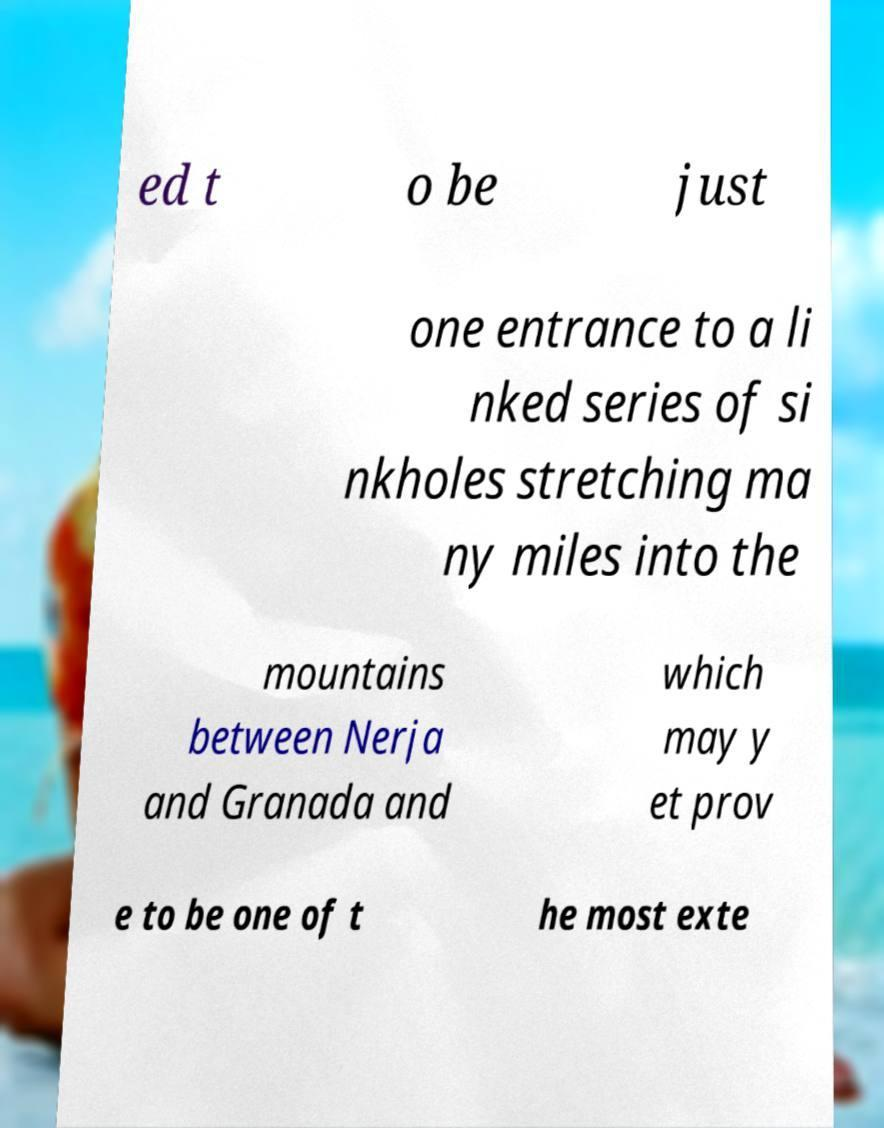Can you read and provide the text displayed in the image?This photo seems to have some interesting text. Can you extract and type it out for me? ed t o be just one entrance to a li nked series of si nkholes stretching ma ny miles into the mountains between Nerja and Granada and which may y et prov e to be one of t he most exte 